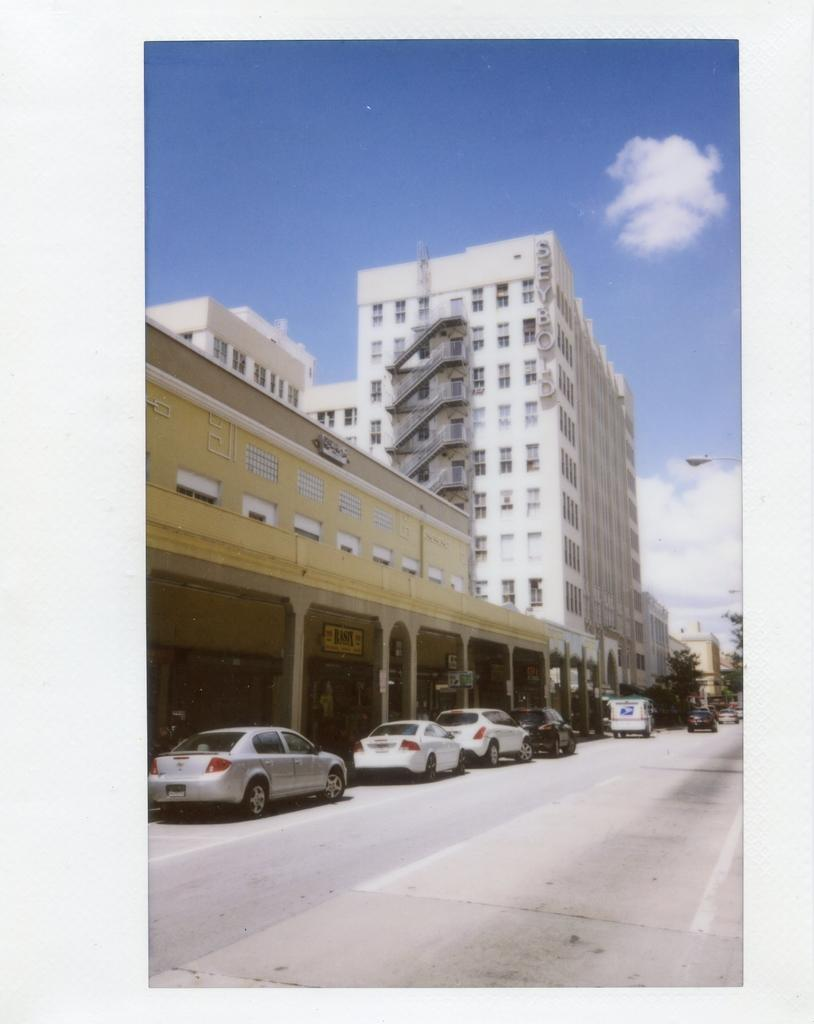What is the main feature of the image? There is a road in the image. What else can be seen on the road? There are vehicles in the image. What type of natural elements are present in the image? There are trees in the image. What type of man-made structures are present in the image? There are buildings in the image. Are there any architectural features visible in the image? Yes, there are stairs in the image. What type of lighting is present in the image? There is a street light in the image. What can be seen in the sky in the image? The sky is visible in the image, and there are clouds present. How many hands can be seen measuring the distance between the buildings in the image? There are no hands or measuring activities present in the image. 